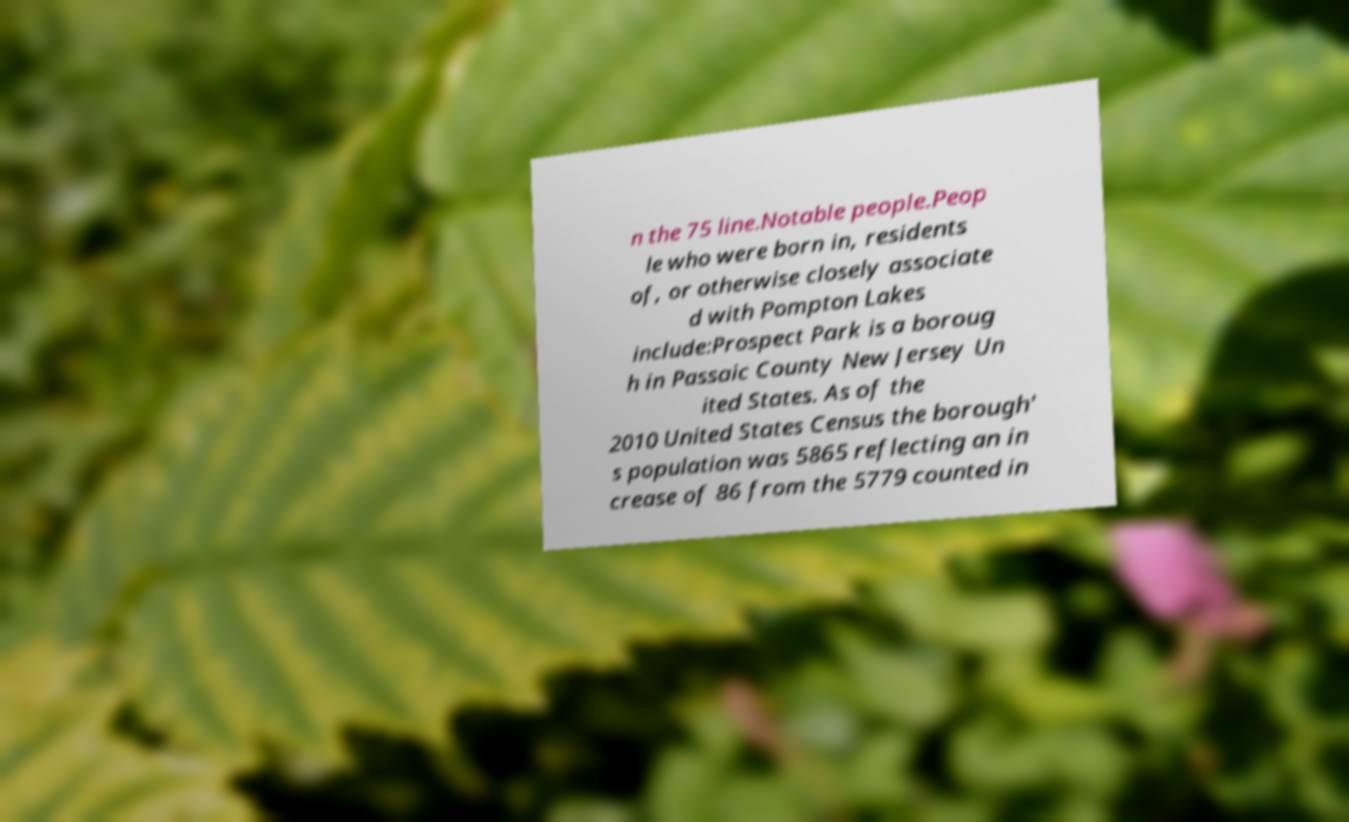What messages or text are displayed in this image? I need them in a readable, typed format. n the 75 line.Notable people.Peop le who were born in, residents of, or otherwise closely associate d with Pompton Lakes include:Prospect Park is a boroug h in Passaic County New Jersey Un ited States. As of the 2010 United States Census the borough' s population was 5865 reflecting an in crease of 86 from the 5779 counted in 